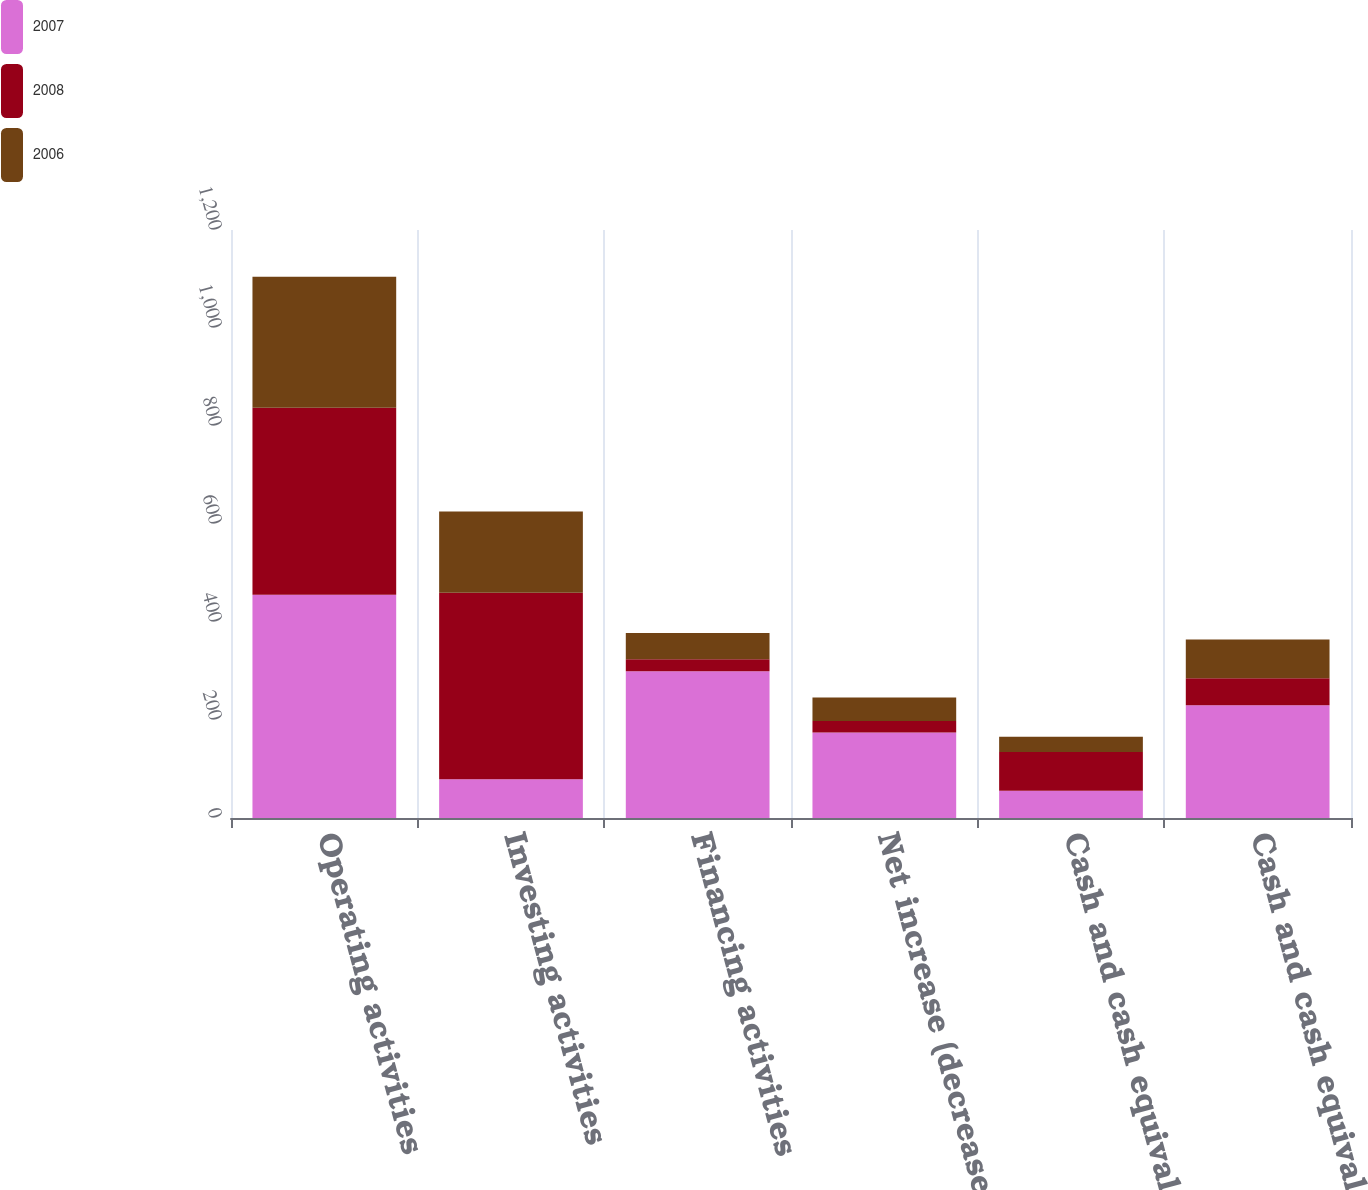Convert chart. <chart><loc_0><loc_0><loc_500><loc_500><stacked_bar_chart><ecel><fcel>Operating activities<fcel>Investing activities<fcel>Financing activities<fcel>Net increase (decrease) in<fcel>Cash and cash equivalents<fcel>Cash and cash equivalents end<nl><fcel>2007<fcel>455.7<fcel>79<fcel>299.4<fcel>174.4<fcel>55.5<fcel>229.9<nl><fcel>2008<fcel>381.5<fcel>380.5<fcel>24.5<fcel>23.5<fcel>79<fcel>55.5<nl><fcel>2006<fcel>267.5<fcel>166<fcel>53.6<fcel>47.9<fcel>31.1<fcel>79<nl></chart> 